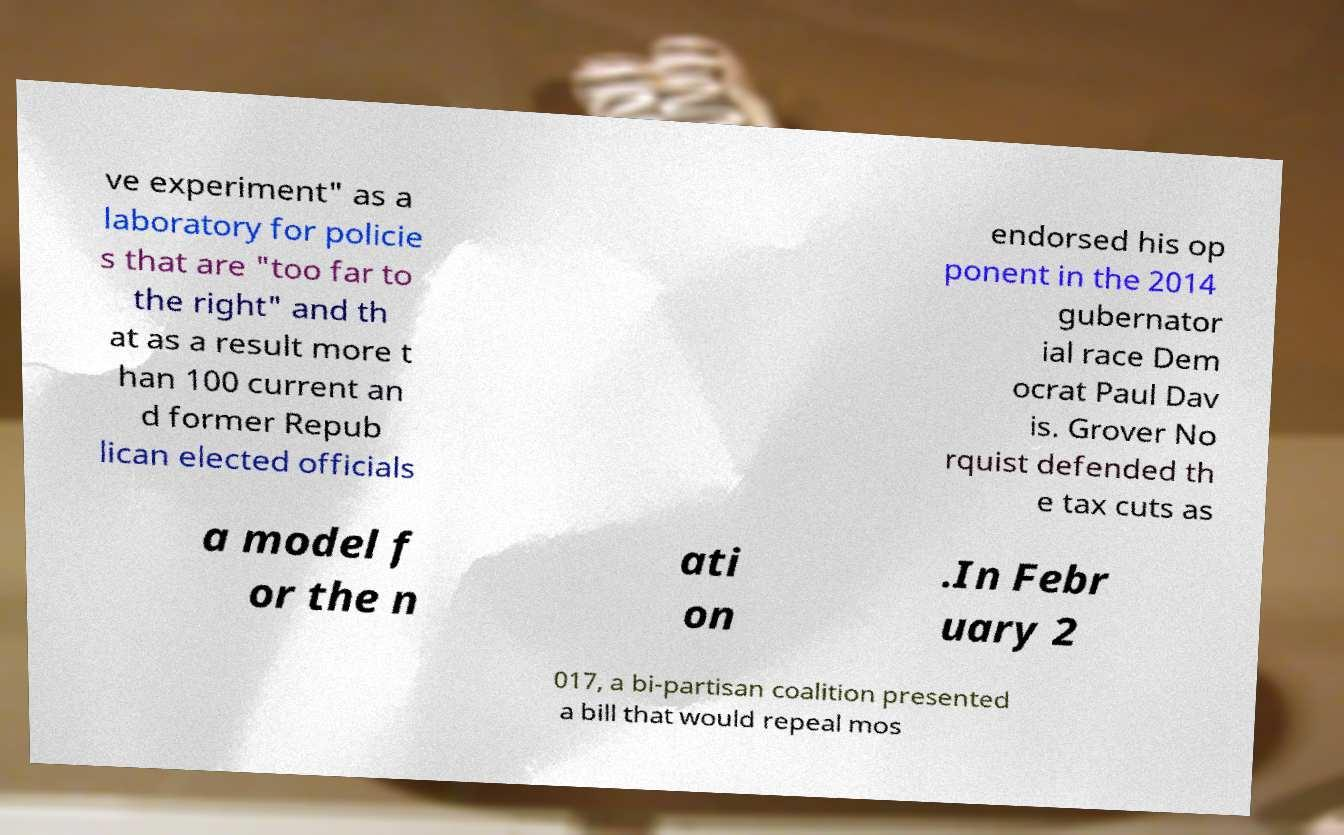For documentation purposes, I need the text within this image transcribed. Could you provide that? ve experiment" as a laboratory for policie s that are "too far to the right" and th at as a result more t han 100 current an d former Repub lican elected officials endorsed his op ponent in the 2014 gubernator ial race Dem ocrat Paul Dav is. Grover No rquist defended th e tax cuts as a model f or the n ati on .In Febr uary 2 017, a bi-partisan coalition presented a bill that would repeal mos 